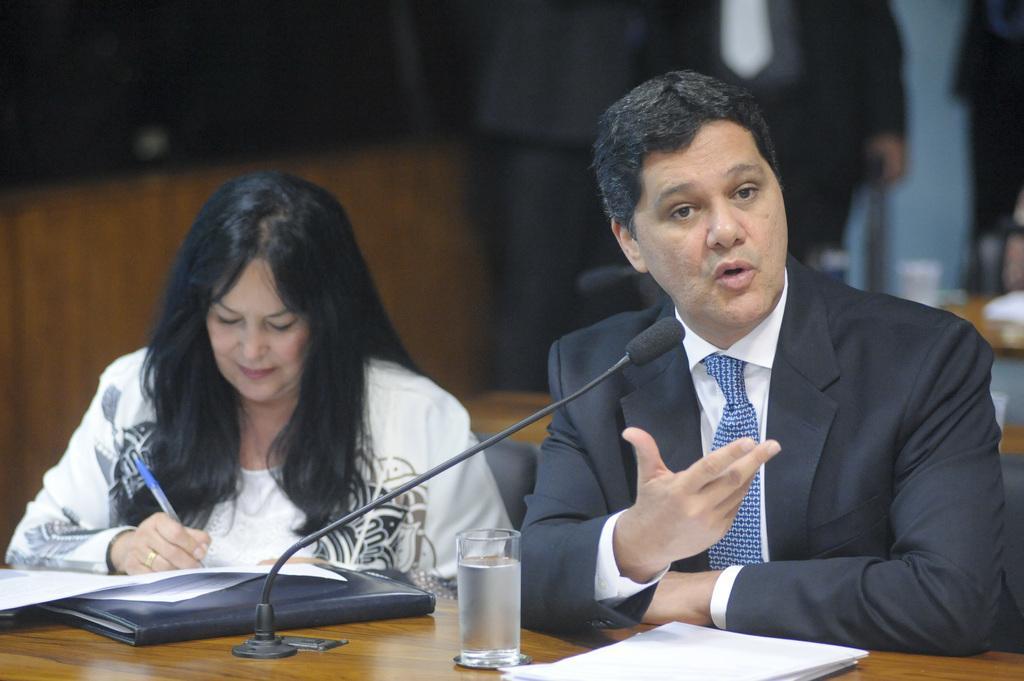In one or two sentences, can you explain what this image depicts? In this picture we can observe two members. One of them is a woman writing on the paper placed on the brown color table and the other is a man wearing a coat. In front of him there is a mic. We can observe file, papers and a glass on the table. In the background there are some people standing. 